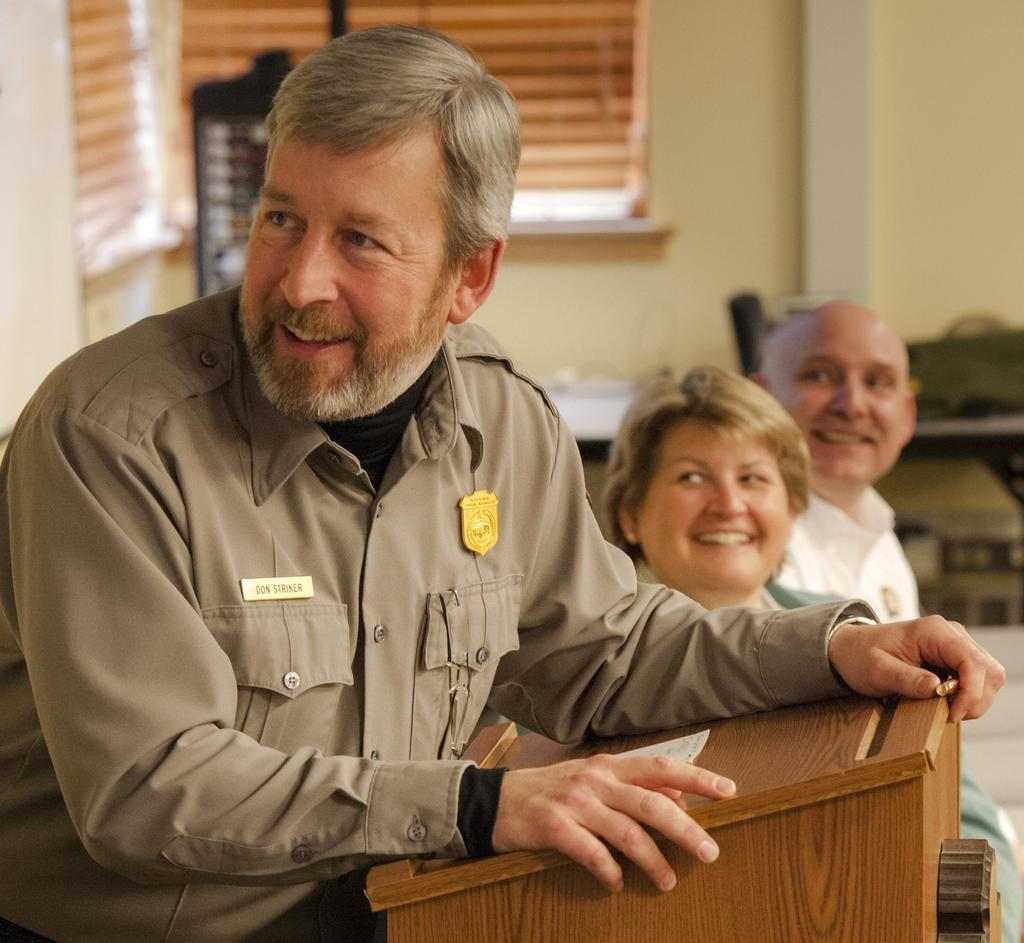How many people are in the image? There are a few people in the image. What is the main object in the image? There is a podium in the image. Can you describe the background of the image? There are objects visible in the background of the image, and there is a wall with a window blind. What is the color of the black colored object in the image? The black colored object in the image is black. How many eyes can be seen on the card in the image? There is no card present in the image, so it is not possible to determine the number of eyes on a card. 